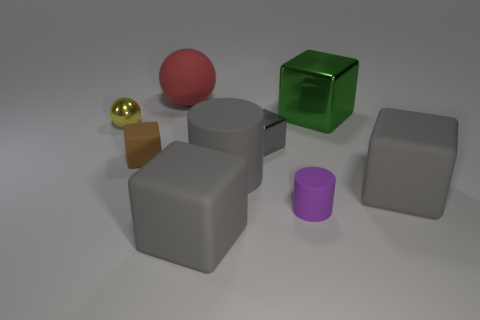There is a rubber cube to the right of the large rubber cylinder; does it have the same color as the big matte cube that is to the left of the gray cylinder?
Your answer should be very brief. Yes. What number of other objects are there of the same color as the big cylinder?
Your answer should be compact. 3. What number of other things are there of the same material as the purple cylinder
Keep it short and to the point. 5. Is there a green metallic object to the left of the tiny metal thing that is on the left side of the small cube that is to the right of the tiny brown block?
Your response must be concise. No. Are the gray cylinder and the big green cube made of the same material?
Your response must be concise. No. Is there any other thing that is the same shape as the big green thing?
Offer a very short reply. Yes. What is the material of the tiny block that is right of the gray thing left of the gray cylinder?
Provide a short and direct response. Metal. What size is the thing left of the brown rubber cube?
Make the answer very short. Small. There is a big thing that is both to the right of the tiny gray thing and behind the brown matte cube; what is its color?
Ensure brevity in your answer.  Green. Does the gray rubber thing that is to the right of the green shiny thing have the same size as the small purple object?
Make the answer very short. No. 